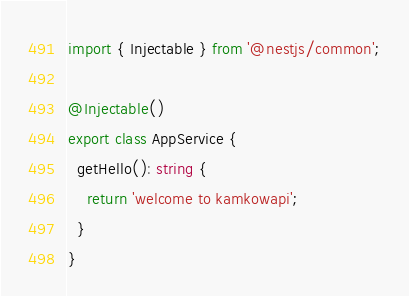Convert code to text. <code><loc_0><loc_0><loc_500><loc_500><_TypeScript_>import { Injectable } from '@nestjs/common';

@Injectable()
export class AppService {
  getHello(): string {
    return 'welcome to kamkowapi';
  }
}
</code> 